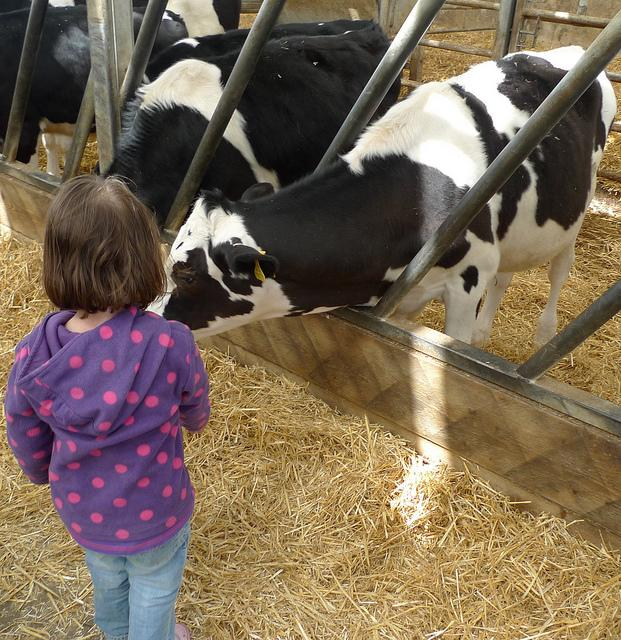What design is on the little girl's hoodie? Please explain your reasoning. polka dots. There are dots around the jacket. 